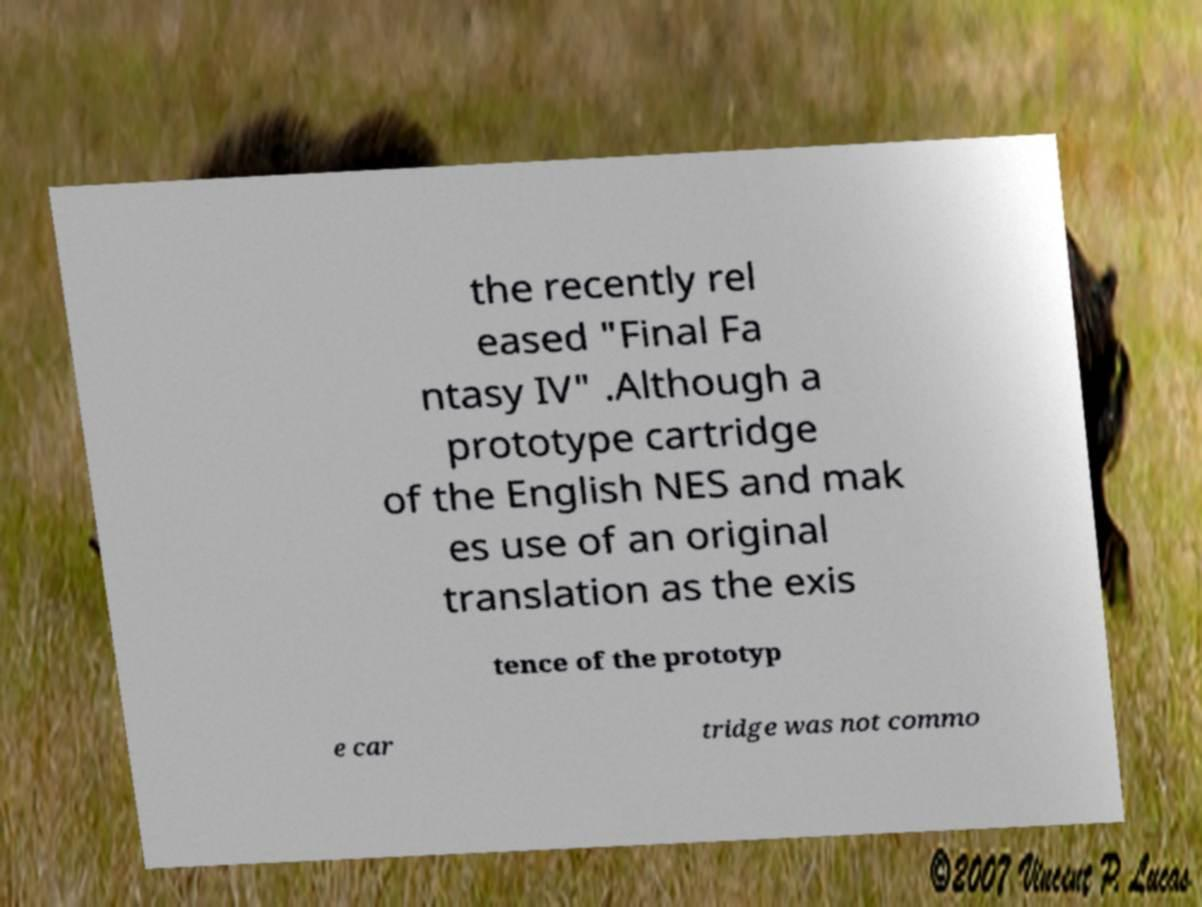Could you assist in decoding the text presented in this image and type it out clearly? the recently rel eased "Final Fa ntasy IV" .Although a prototype cartridge of the English NES and mak es use of an original translation as the exis tence of the prototyp e car tridge was not commo 